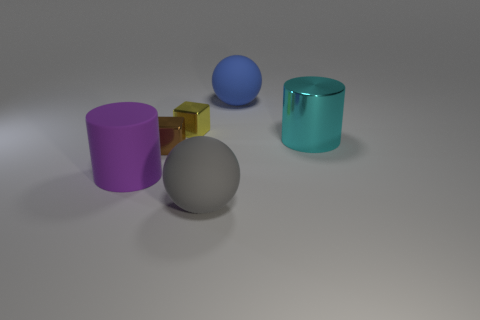Is the shape of the yellow thing in front of the large blue ball the same as  the big cyan metallic thing?
Provide a short and direct response. No. How many things are either tiny brown metal cubes that are in front of the yellow metallic object or brown shiny balls?
Offer a terse response. 1. There is another small metal thing that is the same shape as the brown metal object; what color is it?
Your answer should be compact. Yellow. Are there any other things that are the same color as the big rubber cylinder?
Your response must be concise. No. There is a cylinder that is left of the cyan object; what is its size?
Keep it short and to the point. Large. Does the shiny cylinder have the same color as the matte ball that is behind the yellow block?
Keep it short and to the point. No. How many other objects are the same material as the purple cylinder?
Ensure brevity in your answer.  2. Is the number of large green shiny spheres greater than the number of brown cubes?
Provide a succinct answer. No. Is the color of the rubber ball in front of the rubber cylinder the same as the metallic cylinder?
Offer a terse response. No. The big matte cylinder is what color?
Give a very brief answer. Purple. 